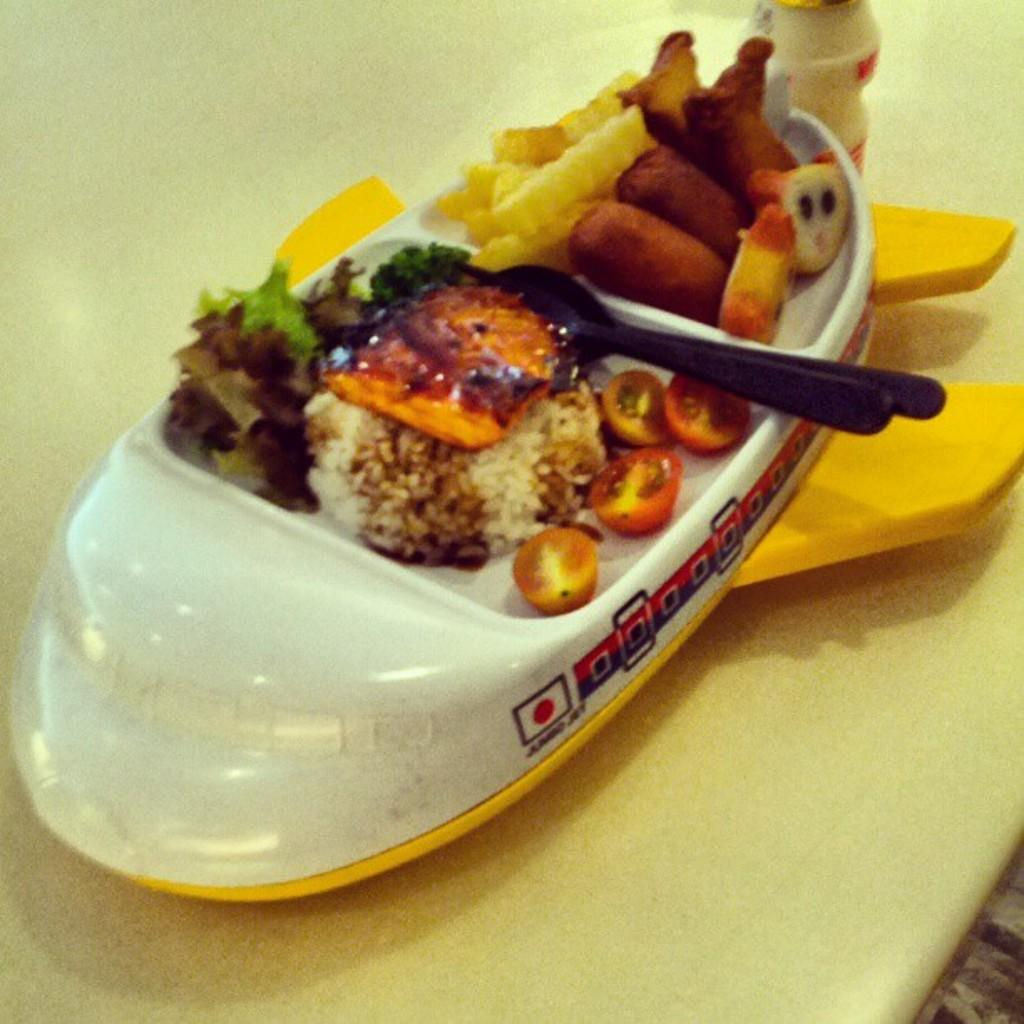What is the shape of the plate in the image? The plate in the image is shaped like a ship. What is on the plate? The plate contains food items. Can you describe the spoon in the image? There is a black spoon in the image. What type of vessel is used to boil water in the image? There is no vessel used to boil water present in the image. How does the friction between the spoon and the plate affect the food in the image? The image does not show any friction between the spoon and the plate, so it cannot be determined how it affects the food. 